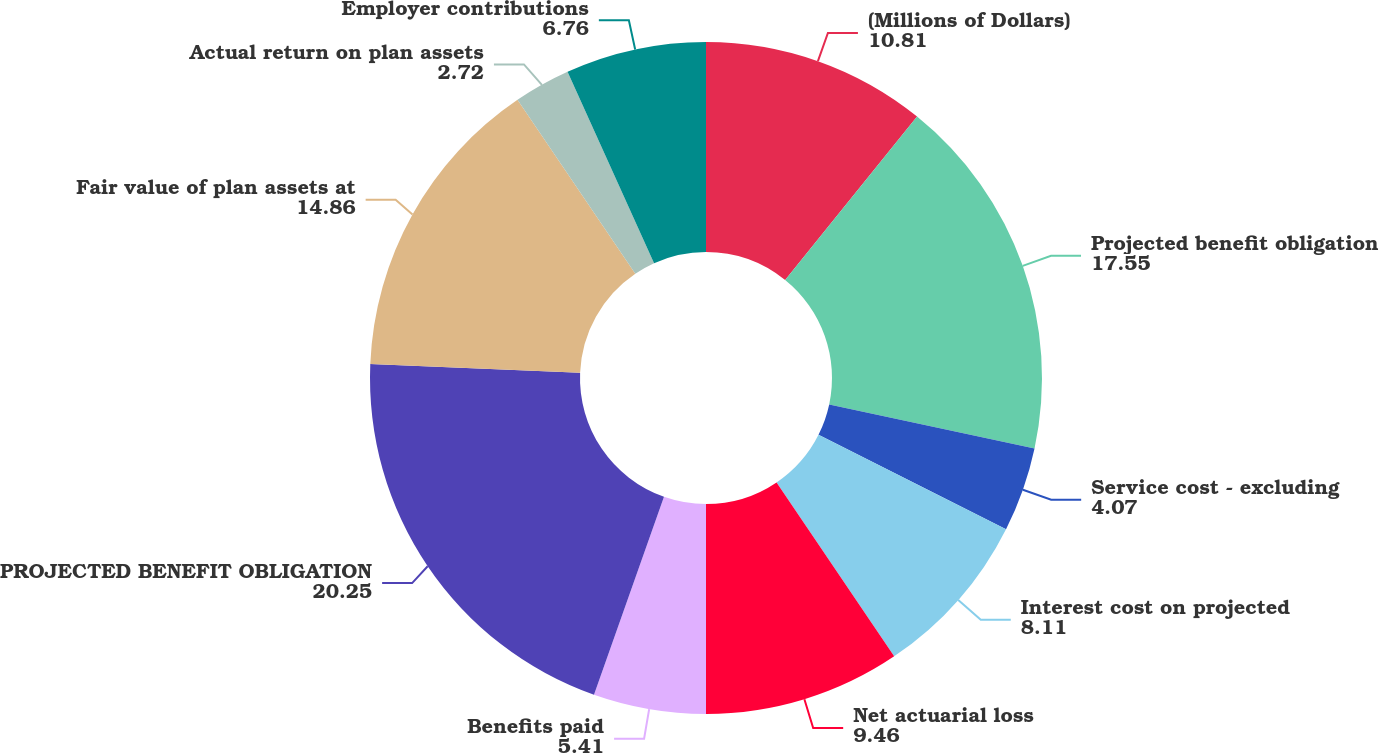Convert chart. <chart><loc_0><loc_0><loc_500><loc_500><pie_chart><fcel>(Millions of Dollars)<fcel>Projected benefit obligation<fcel>Service cost - excluding<fcel>Interest cost on projected<fcel>Net actuarial loss<fcel>Benefits paid<fcel>PROJECTED BENEFIT OBLIGATION<fcel>Fair value of plan assets at<fcel>Actual return on plan assets<fcel>Employer contributions<nl><fcel>10.81%<fcel>17.55%<fcel>4.07%<fcel>8.11%<fcel>9.46%<fcel>5.41%<fcel>20.25%<fcel>14.86%<fcel>2.72%<fcel>6.76%<nl></chart> 